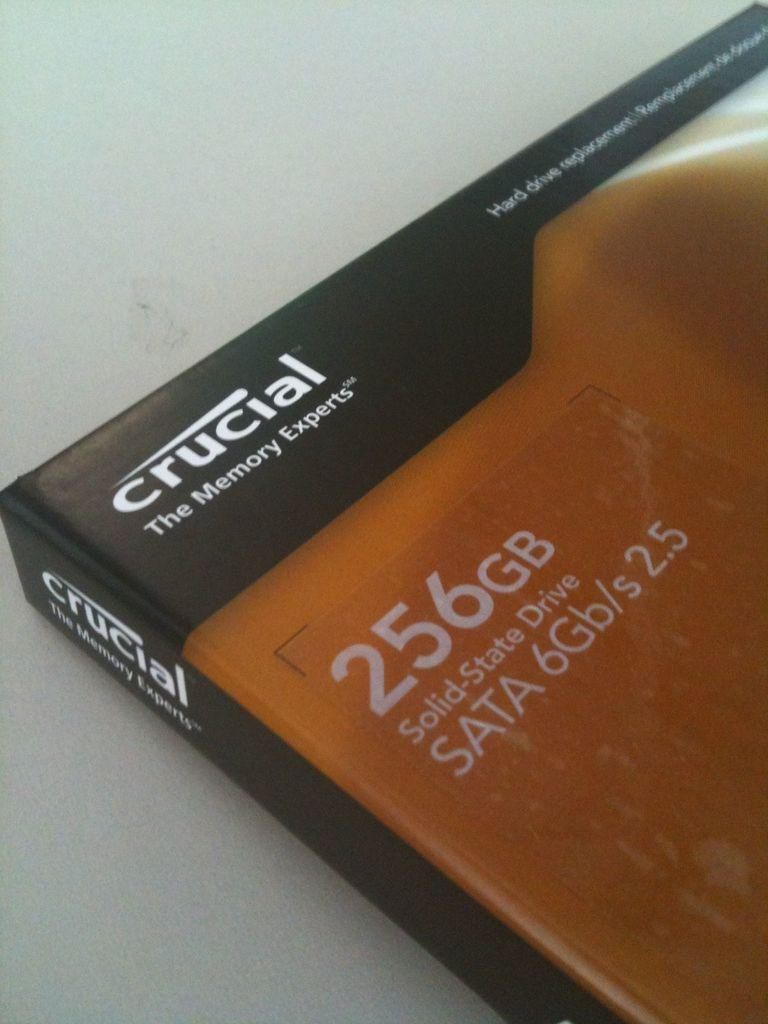<image>
Provide a brief description of the given image. The book is titled Crucial The Memory Experts. 